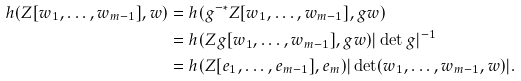Convert formula to latex. <formula><loc_0><loc_0><loc_500><loc_500>h ( Z [ w _ { 1 } , \dots , w _ { m - 1 } ] , w ) & = h ( g ^ { - * } Z [ w _ { 1 } , \dots , w _ { m - 1 } ] , g w ) \\ & = h ( Z g [ w _ { 1 } , \dots , w _ { m - 1 } ] , g w ) | \det g | ^ { - 1 } \\ & = h ( Z [ e _ { 1 } , \dots , e _ { m - 1 } ] , e _ { m } ) | \det ( w _ { 1 } , \dots , w _ { m - 1 } , w ) | .</formula> 